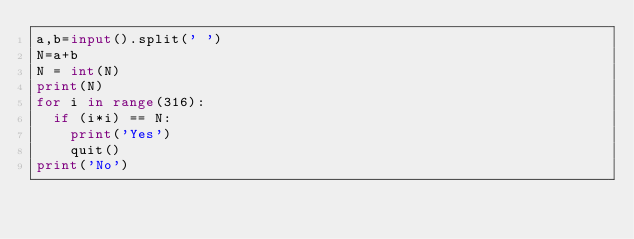<code> <loc_0><loc_0><loc_500><loc_500><_Python_>a,b=input().split(' ')
N=a+b
N = int(N)
print(N)
for i in range(316):
	if (i*i) == N:
		print('Yes')
		quit()
print('No')</code> 